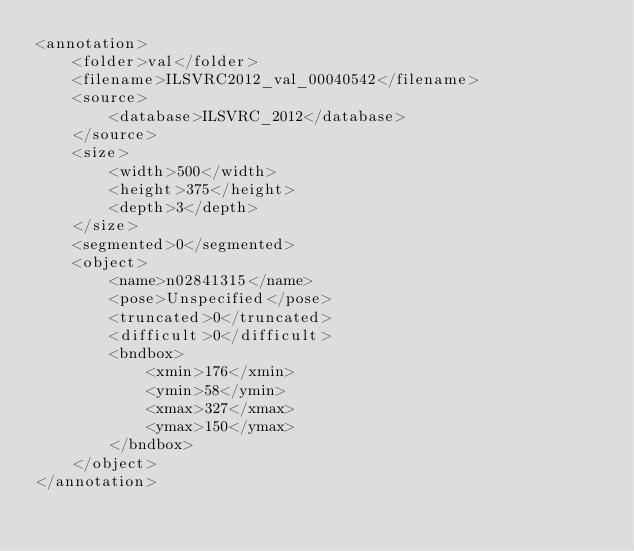<code> <loc_0><loc_0><loc_500><loc_500><_XML_><annotation>
	<folder>val</folder>
	<filename>ILSVRC2012_val_00040542</filename>
	<source>
		<database>ILSVRC_2012</database>
	</source>
	<size>
		<width>500</width>
		<height>375</height>
		<depth>3</depth>
	</size>
	<segmented>0</segmented>
	<object>
		<name>n02841315</name>
		<pose>Unspecified</pose>
		<truncated>0</truncated>
		<difficult>0</difficult>
		<bndbox>
			<xmin>176</xmin>
			<ymin>58</ymin>
			<xmax>327</xmax>
			<ymax>150</ymax>
		</bndbox>
	</object>
</annotation></code> 